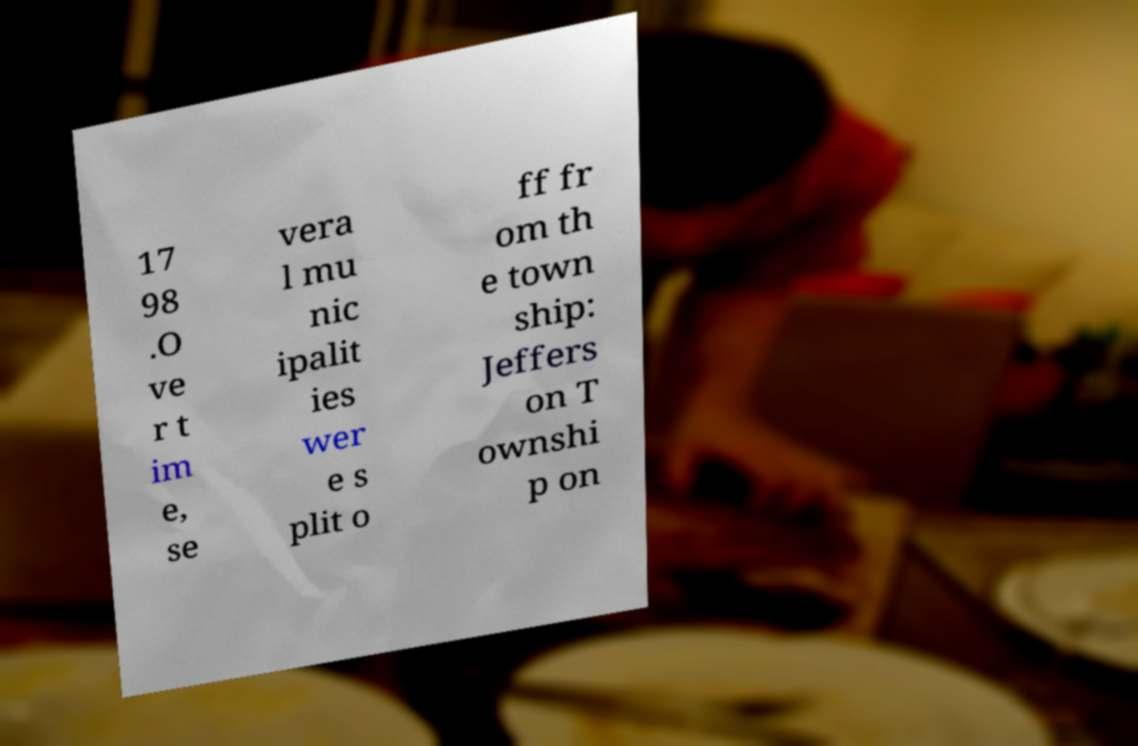Could you extract and type out the text from this image? 17 98 .O ve r t im e, se vera l mu nic ipalit ies wer e s plit o ff fr om th e town ship: Jeffers on T ownshi p on 